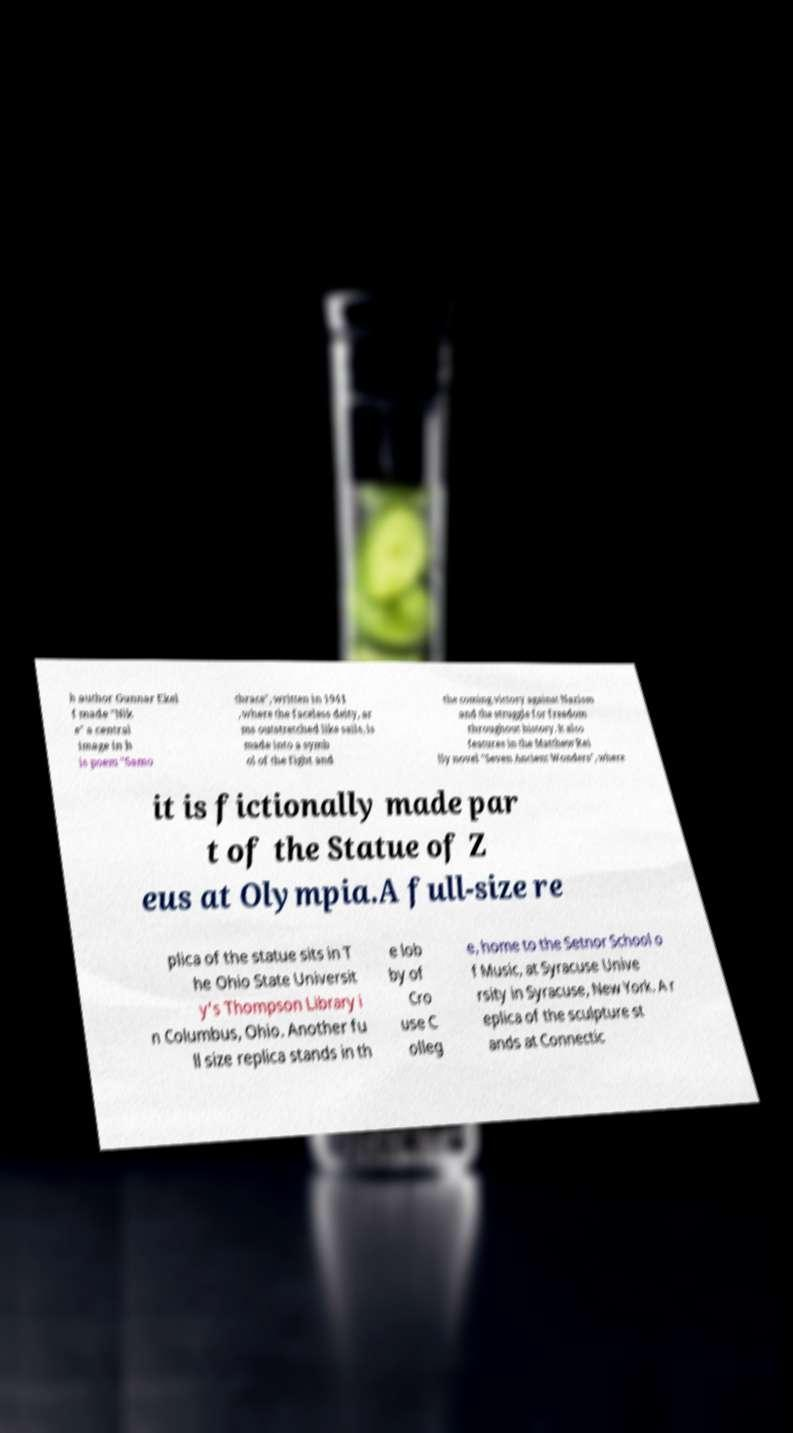There's text embedded in this image that I need extracted. Can you transcribe it verbatim? h author Gunnar Ekel f made "Nik e" a central image in h is poem "Samo thrace", written in 1941 , where the faceless deity, ar ms outstretched like sails, is made into a symb ol of the fight and the coming victory against Nazism and the struggle for freedom throughout history. It also features in the Matthew Rei lly novel "Seven Ancient Wonders", where it is fictionally made par t of the Statue of Z eus at Olympia.A full-size re plica of the statue sits in T he Ohio State Universit y's Thompson Library i n Columbus, Ohio. Another fu ll size replica stands in th e lob by of Cro use C olleg e, home to the Setnor School o f Music, at Syracuse Unive rsity in Syracuse, New York. A r eplica of the sculpture st ands at Connectic 